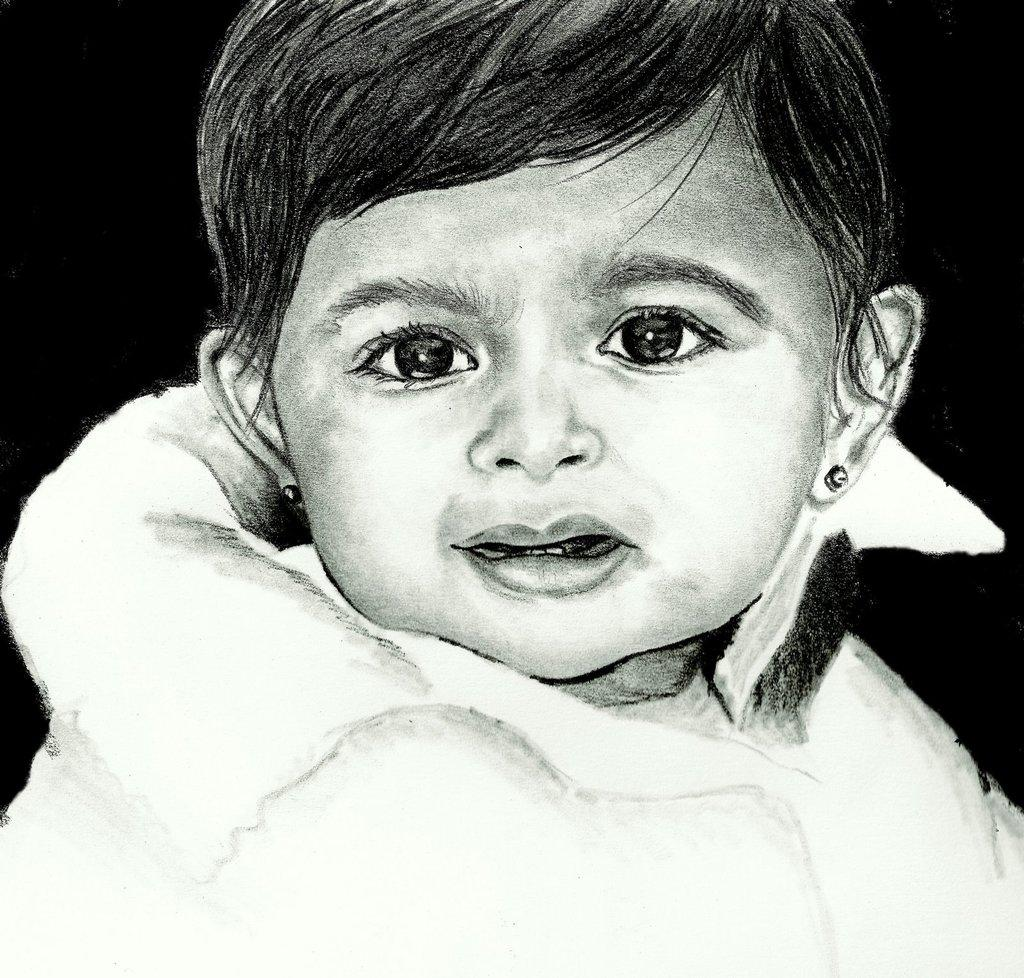What type of art is depicted in the image? The image is an art of paintings. Can you describe the subject of the painting? There is a girl in the image. What is the girl wearing? The girl is wearing a white dress. What expression does the girl have? The girl is smiling. What is the color of the background in the image? The background of the image is black in color. What type of copper range can be seen in the image? There is no copper range present in the image; it is a painting features a girl with a black background. Can you tell me how many socks the girl is wearing in the image? There is no information about socks in the image, as it only shows a girl wearing a white dress with a black background. 